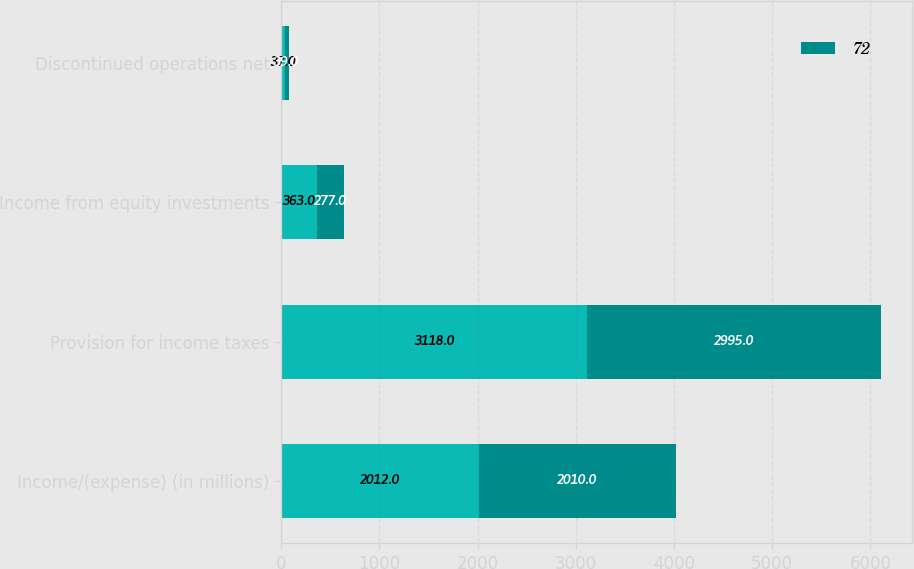<chart> <loc_0><loc_0><loc_500><loc_500><stacked_bar_chart><ecel><fcel>Income/(expense) (in millions)<fcel>Provision for income taxes<fcel>Income from equity investments<fcel>Discontinued operations net<nl><fcel>nan<fcel>2012<fcel>3118<fcel>363<fcel>37<nl><fcel>72<fcel>2010<fcel>2995<fcel>277<fcel>39<nl></chart> 